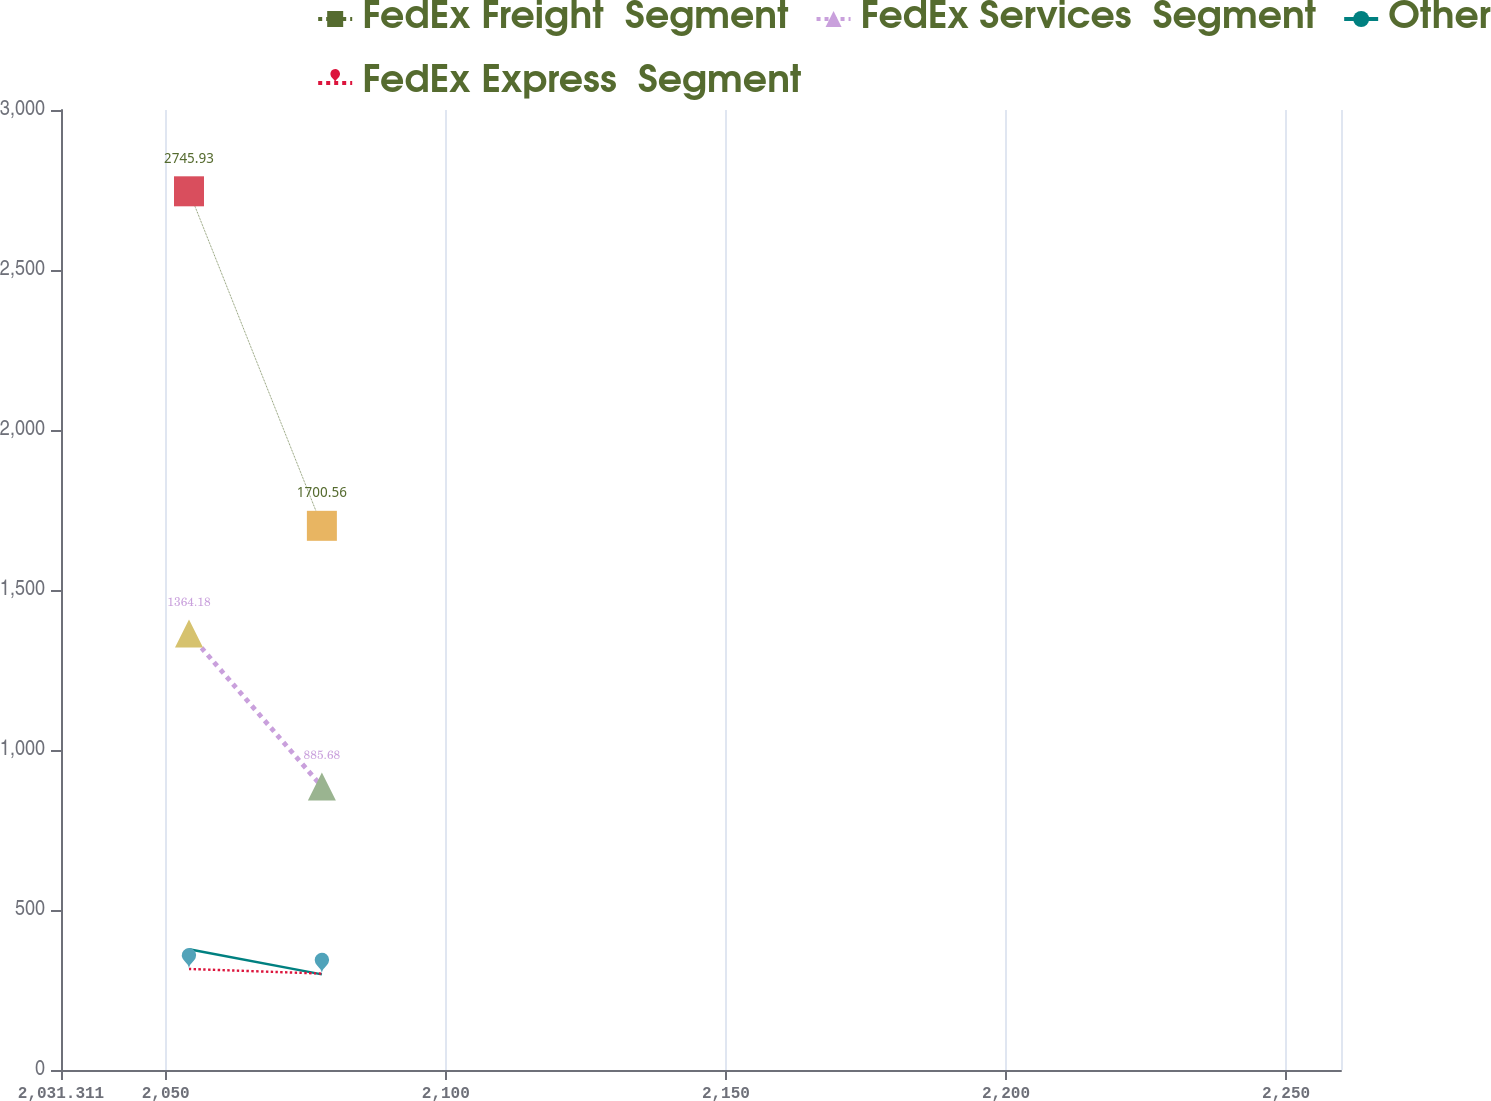<chart> <loc_0><loc_0><loc_500><loc_500><line_chart><ecel><fcel>FedEx Freight  Segment<fcel>FedEx Services  Segment<fcel>Other<fcel>FedEx Express  Segment<nl><fcel>2054.16<fcel>2745.93<fcel>1364.18<fcel>377.49<fcel>315.75<nl><fcel>2077.88<fcel>1700.56<fcel>885.68<fcel>298.9<fcel>301.24<nl><fcel>2282.65<fcel>1805.1<fcel>544.6<fcel>321.75<fcel>440.03<nl></chart> 